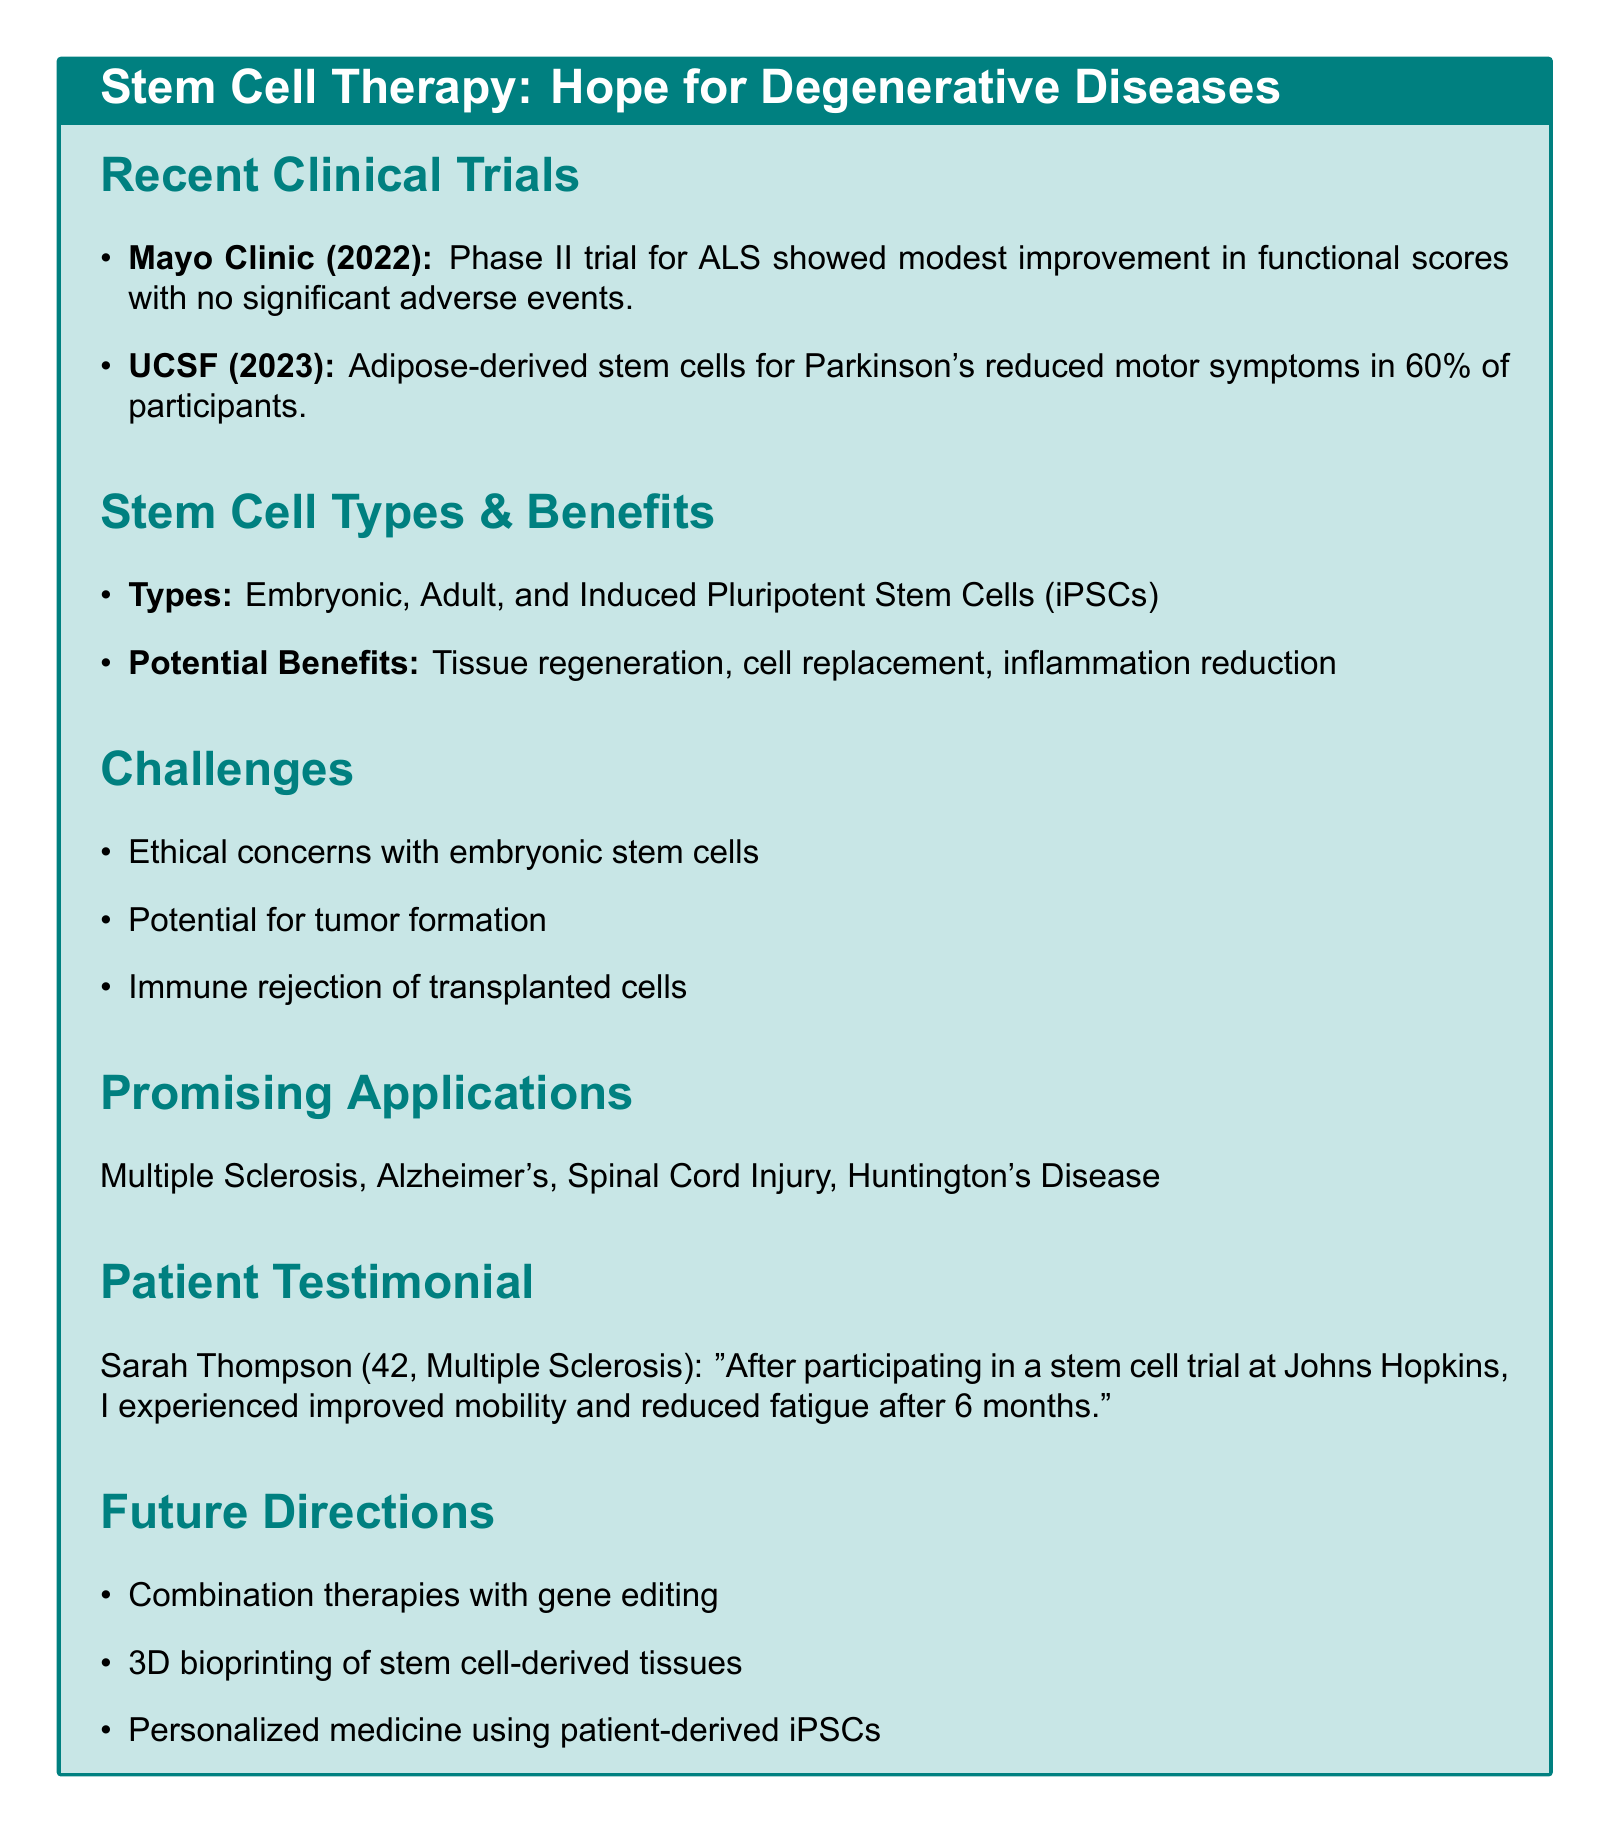What is the title of the trial conducted at the Mayo Clinic? The title of the trial is specifically mentioned in the document.
Answer: Phase II Trial of Mesenchymal Stem Cells for Amyotrophic Lateral Sclerosis What year was the UCSF trial on adipose-derived stem cells conducted? The document lists the year for the UCSF trial directly.
Answer: 2023 What percentage of participants experienced reduced motor symptoms in the UCSF trial? This percentage is specified as a key finding in the trial results.
Answer: 60% Which hospital did Sarah Thompson participate in for her stem cell trial? The document includes the name of the hospital where the trial took place.
Answer: Johns Hopkins What are two potential benefits of stem cell therapy mentioned in the document? The document lists multiple potential benefits; two can be extracted from this list.
Answer: Tissue regeneration, cell replacement What is a challenge associated with using embryonic stem cells? The document provides a list of challenges that includes ethical concerns with embryonic stem cells.
Answer: Ethical concerns What degenerative disease is specifically mentioned as a promising application for stem cell therapy? This is one of the diseases highlighted for potential benefits from stem cell therapy in the document.
Answer: Multiple Sclerosis What future direction involves patient-derived iPSCs? The document refers to future directions for stem cell research, including personalized medicine using patient-derived iPSCs.
Answer: Personalized medicine approaches using patient-derived iPSCs 